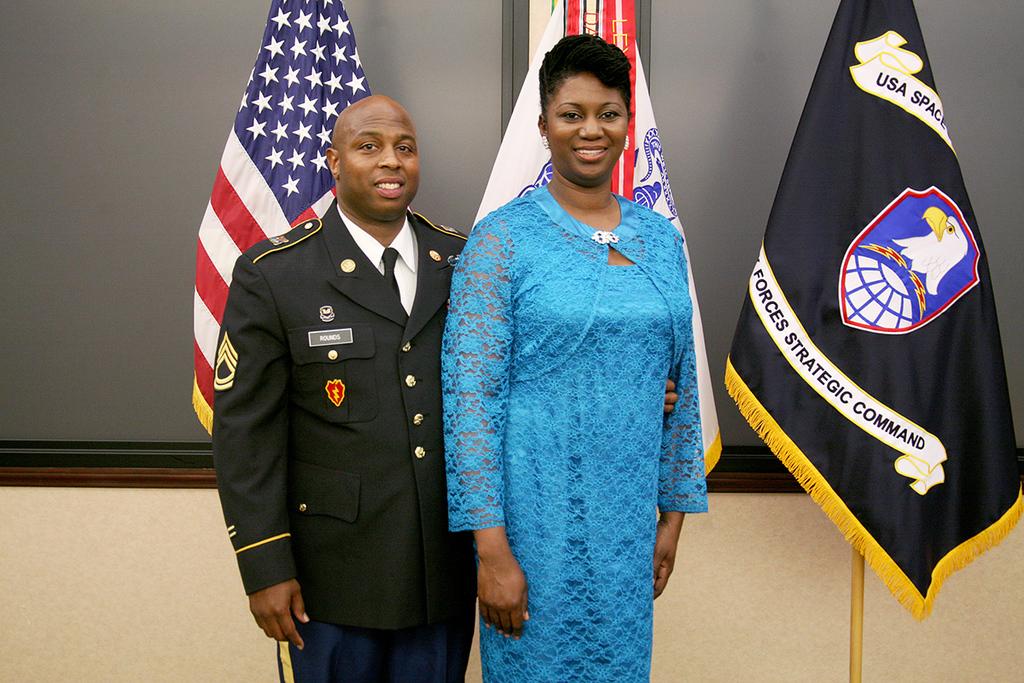What is written on the flag to the right of the people?
Provide a short and direct response. Forces strategic command. What is the country on top of the black flag?
Your answer should be compact. Usa. 